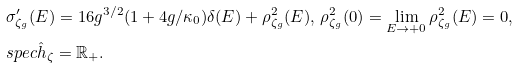<formula> <loc_0><loc_0><loc_500><loc_500>& \sigma _ { \zeta _ { g } } ^ { \prime } ( E ) = 1 6 g ^ { 3 / 2 } ( 1 + 4 g / \kappa _ { 0 } ) \delta ( E ) + \rho _ { \zeta _ { g } } ^ { 2 } ( E ) , \, \rho _ { \zeta _ { g } } ^ { 2 } ( 0 ) = \lim _ { E \rightarrow + 0 } \rho _ { \zeta _ { g } } ^ { 2 } ( E ) = 0 , \\ & s p e c \hat { h } _ { \zeta } = \mathbb { R } _ { + } .</formula> 